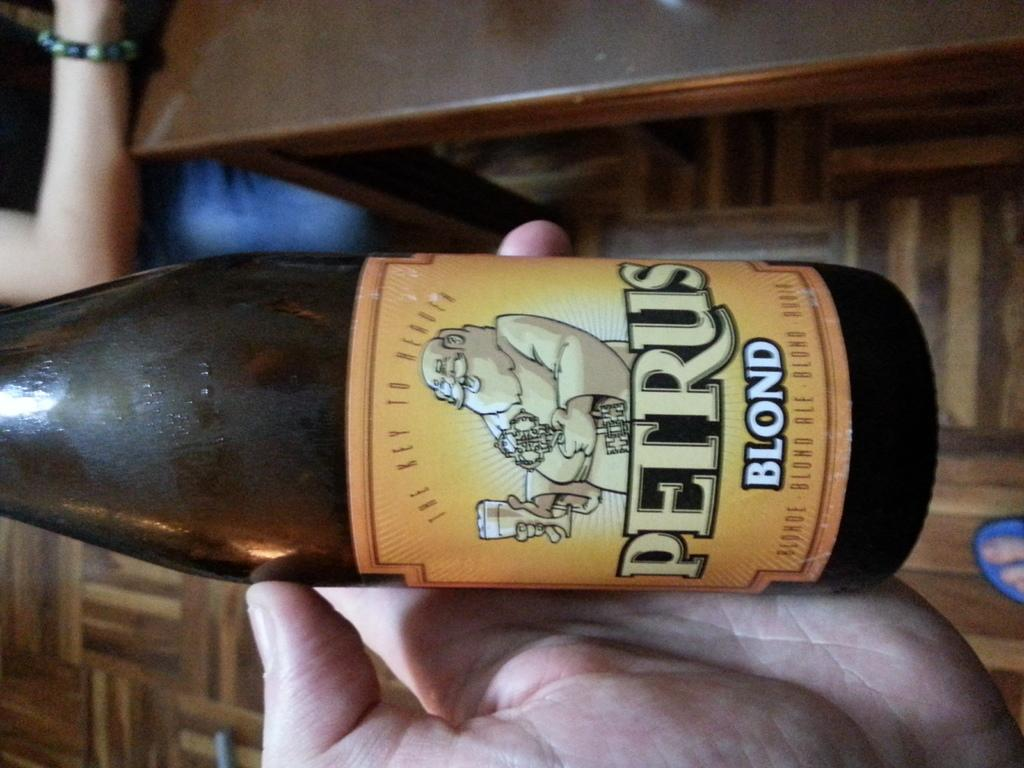<image>
Provide a brief description of the given image. A hand holds a bottle of Petrus Blond. 